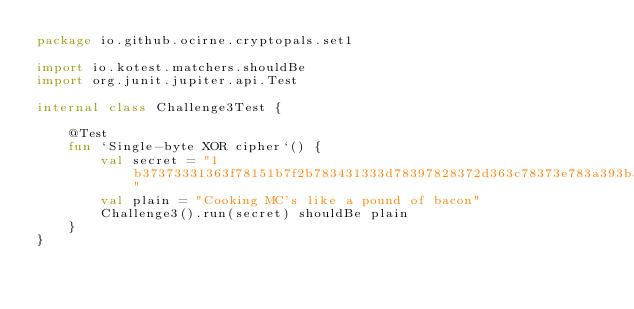<code> <loc_0><loc_0><loc_500><loc_500><_Kotlin_>package io.github.ocirne.cryptopals.set1

import io.kotest.matchers.shouldBe
import org.junit.jupiter.api.Test

internal class Challenge3Test {

    @Test
    fun `Single-byte XOR cipher`() {
        val secret = "1b37373331363f78151b7f2b783431333d78397828372d363c78373e783a393b3736"
        val plain = "Cooking MC's like a pound of bacon"
        Challenge3().run(secret) shouldBe plain
    }
}
</code> 